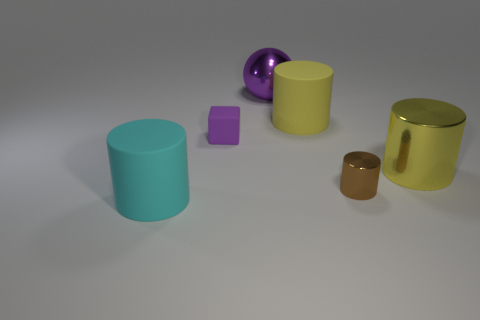Add 1 large cyan matte objects. How many objects exist? 7 Subtract all cylinders. How many objects are left? 2 Add 4 cylinders. How many cylinders are left? 8 Add 6 purple objects. How many purple objects exist? 8 Subtract 0 yellow blocks. How many objects are left? 6 Subtract all tiny matte cubes. Subtract all big cyan matte cubes. How many objects are left? 5 